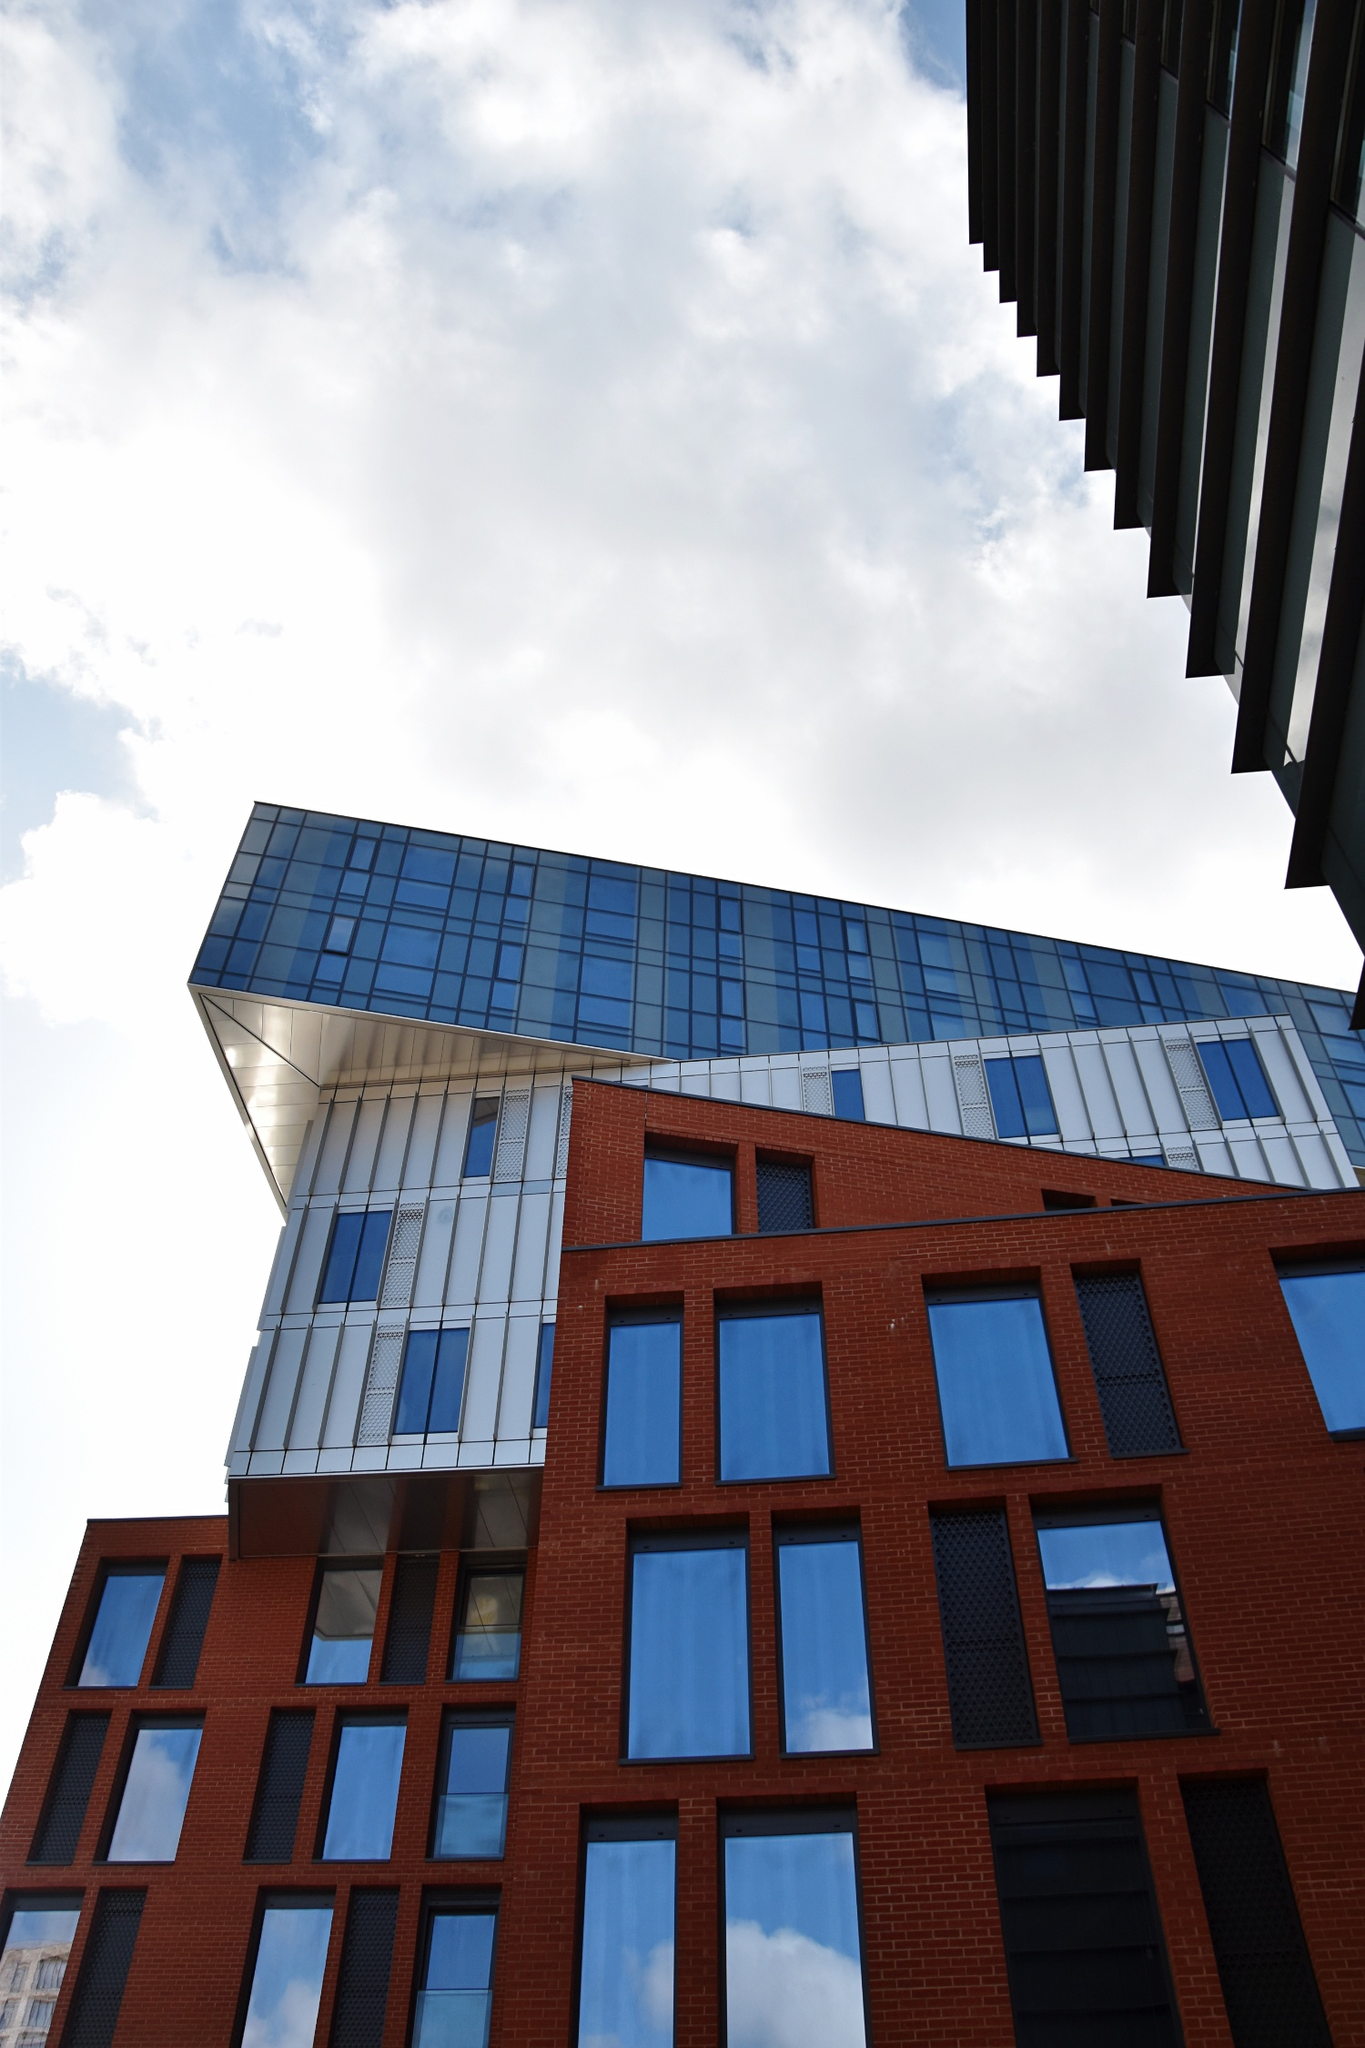If this building could talk, what stories would it tell? If this building could share its stories, it would narrate tales of its inception and the creative minds that designed it. It might talk about the countless hours of planning and the vision behind its unique blend of materials and forms. It would recount the bustling city life it witnesses daily through its large, reflective windows - the rush of people, the changing fashion styles, and the evolving urban landscape. It would also share quieter moments, like the calm after a rainstorm reflecting the clear sky on its glass surfaces, or the golden hues of sunsets painting its facade. This building, standing tall and resolute, could chronicle the history of its neighborhood, the events that shaped it, and the lives it silently observes. That's fascinating! Could you tell me more about the architectural elements and materials used in this design? Absolutely! The building's design cleverly melds traditional and contemporary architectural elements. The red brick used in the lower portion of the facade is a nod to classical architecture, providing a sense of warmth and history. This is juxtaposed with modern elements like the blue-tinted glass panels that dominate the upper sections of the structure. The glass not only offers a sleek, modern aesthetic but also serves practical purposes such as energy efficiency and enhanced natural lighting.

Another key element is the building's geometric juxtaposition. The red brick part of the building features a repetitive grid pattern with windows that create a rhythmic visual appeal. In contrast, the glass tower above is characterized by its angular design, jutting out to create a dynamic silhouette. This contrast between the heavy, textured brick and the light, reflective glass embodies a balance between solidity and transparency, tradition and modernity.

Additionally, the staggered design includes elements of cantilevering, where parts of the structure extend beyond their base. This not only adds an element of drama to the building's profile but also maximizes the use of space and creates interesting overhangs and shadow patterns. Overall, the blend of these materials and elements results in a building that is both functional and a piece of art. 